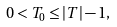<formula> <loc_0><loc_0><loc_500><loc_500>0 < T _ { 0 } \leq | T | - 1 ,</formula> 